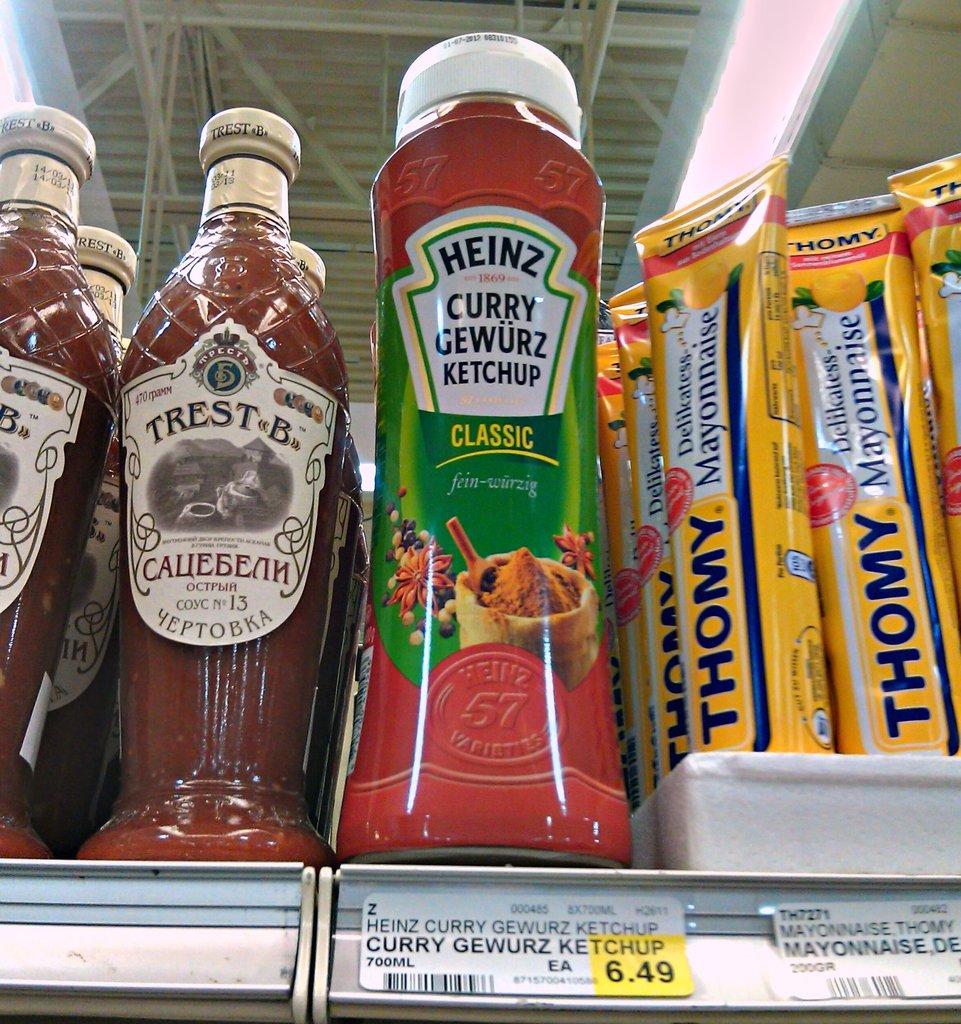What is the brand name of the yellow product?
Give a very brief answer. Thomy. 